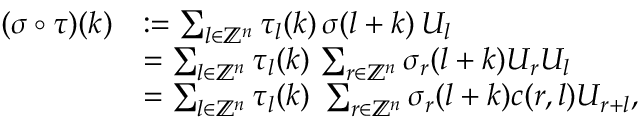Convert formula to latex. <formula><loc_0><loc_0><loc_500><loc_500>\begin{array} { r l } { ( \sigma \circ \tau ) ( k ) } & { \colon = \sum _ { l \in \mathbb { Z } ^ { n } } \tau _ { l } ( k ) \, \sigma ( l + k ) \, U _ { l } } \\ & { = \sum _ { l \in \mathbb { Z } ^ { n } } \tau _ { l } ( k ) \, \sum _ { r \in \mathbb { Z } ^ { n } } \sigma _ { r } ( l + k ) U _ { r } U _ { l } } \\ & { = \sum _ { l \in \mathbb { Z } ^ { n } } \tau _ { l } ( k ) \, \sum _ { r \in \mathbb { Z } ^ { n } } \sigma _ { r } ( l + k ) c ( r , l ) U _ { r + l } , } \end{array}</formula> 